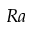Convert formula to latex. <formula><loc_0><loc_0><loc_500><loc_500>R a</formula> 